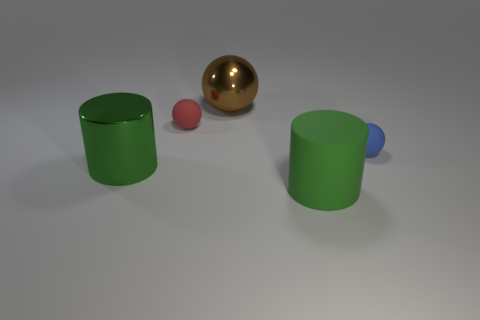Add 3 green shiny objects. How many objects exist? 8 Subtract all spheres. How many objects are left? 2 Subtract all tiny cyan metal spheres. Subtract all big green metal cylinders. How many objects are left? 4 Add 3 tiny blue objects. How many tiny blue objects are left? 4 Add 2 rubber blocks. How many rubber blocks exist? 2 Subtract 0 blue cylinders. How many objects are left? 5 